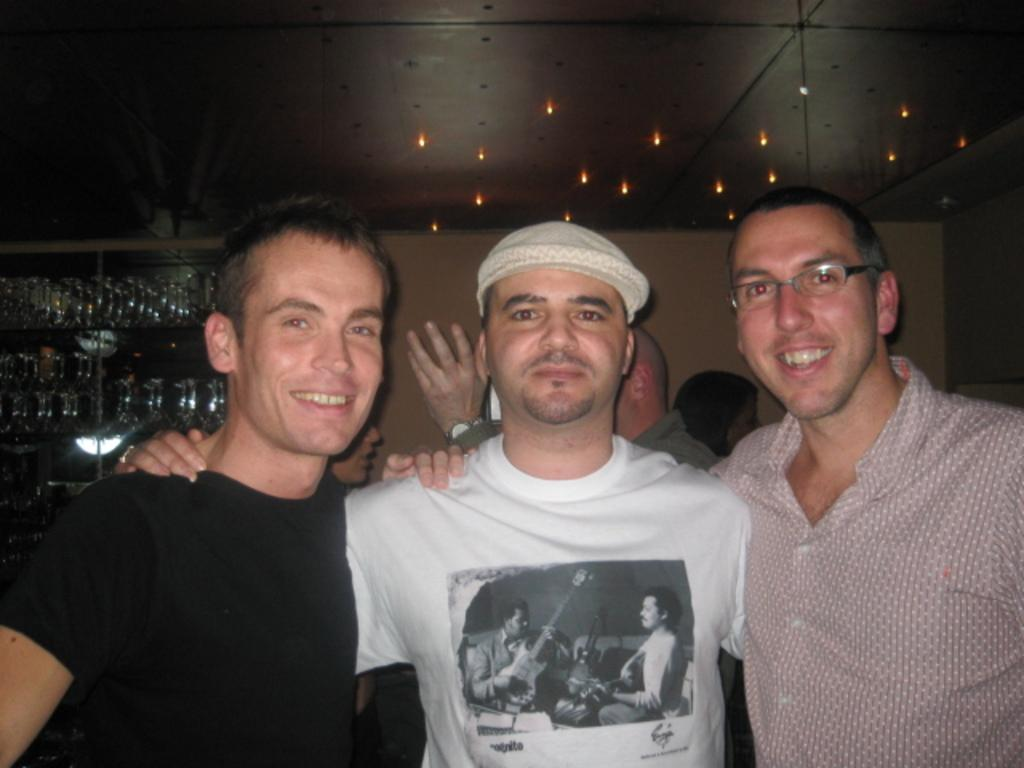How many men are in the foreground of the image? There are three men in the foreground of the image. Can you describe the background of the image? There are other men in the background of the image. What type of lighting is present in the image? There are lights on the ceiling and on shelves in the image. Are there any children playing in the market in the image? There is no mention of children or a market in the image; it only features men and lighting. 